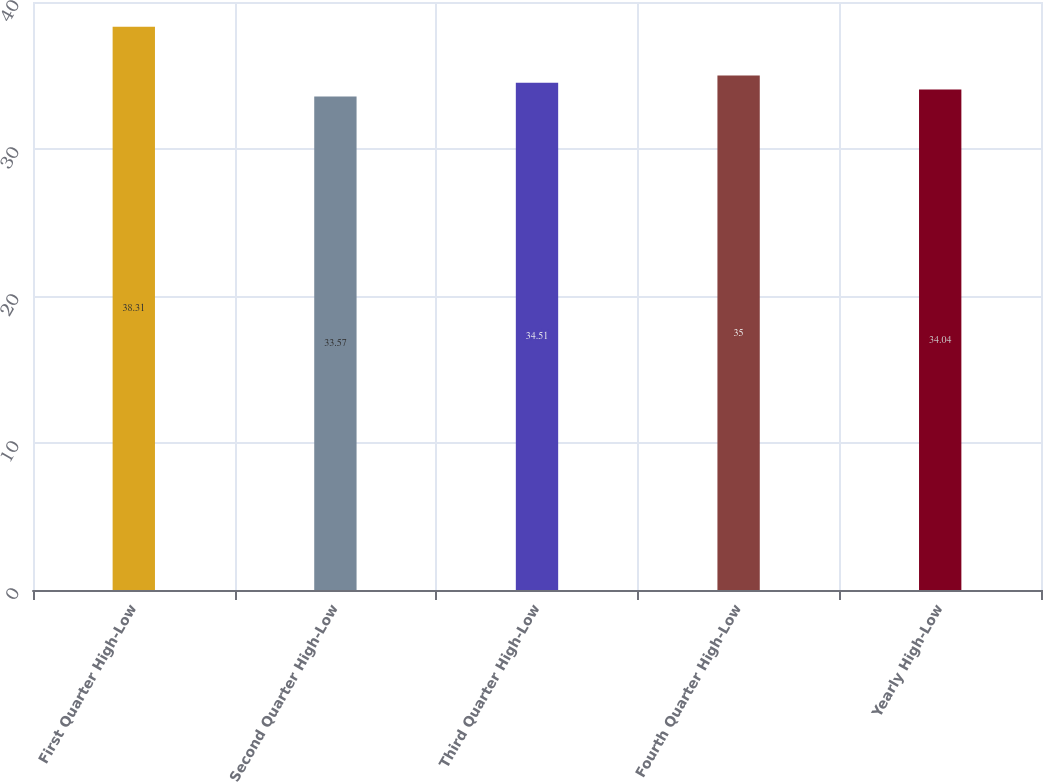Convert chart. <chart><loc_0><loc_0><loc_500><loc_500><bar_chart><fcel>First Quarter High-Low<fcel>Second Quarter High-Low<fcel>Third Quarter High-Low<fcel>Fourth Quarter High-Low<fcel>Yearly High-Low<nl><fcel>38.31<fcel>33.57<fcel>34.51<fcel>35<fcel>34.04<nl></chart> 